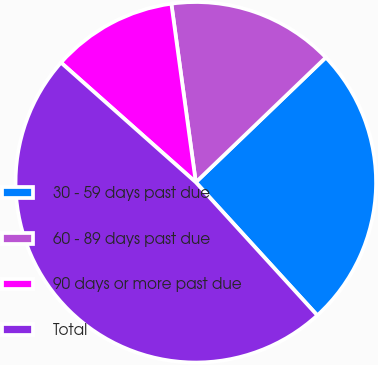<chart> <loc_0><loc_0><loc_500><loc_500><pie_chart><fcel>30 - 59 days past due<fcel>60 - 89 days past due<fcel>90 days or more past due<fcel>Total<nl><fcel>25.4%<fcel>14.99%<fcel>11.28%<fcel>48.33%<nl></chart> 